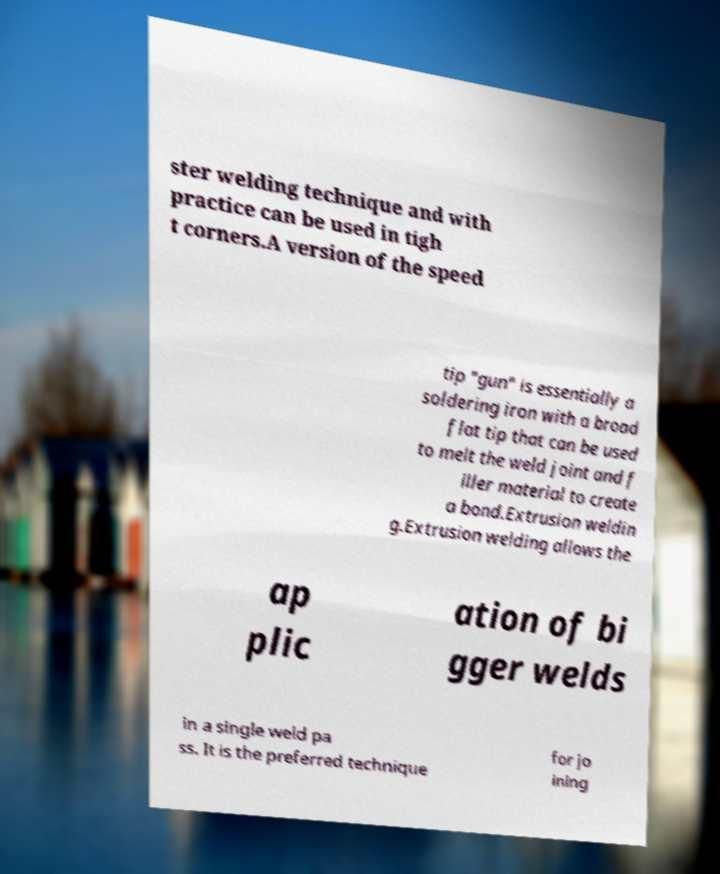For documentation purposes, I need the text within this image transcribed. Could you provide that? ster welding technique and with practice can be used in tigh t corners.A version of the speed tip "gun" is essentially a soldering iron with a broad flat tip that can be used to melt the weld joint and f iller material to create a bond.Extrusion weldin g.Extrusion welding allows the ap plic ation of bi gger welds in a single weld pa ss. It is the preferred technique for jo ining 